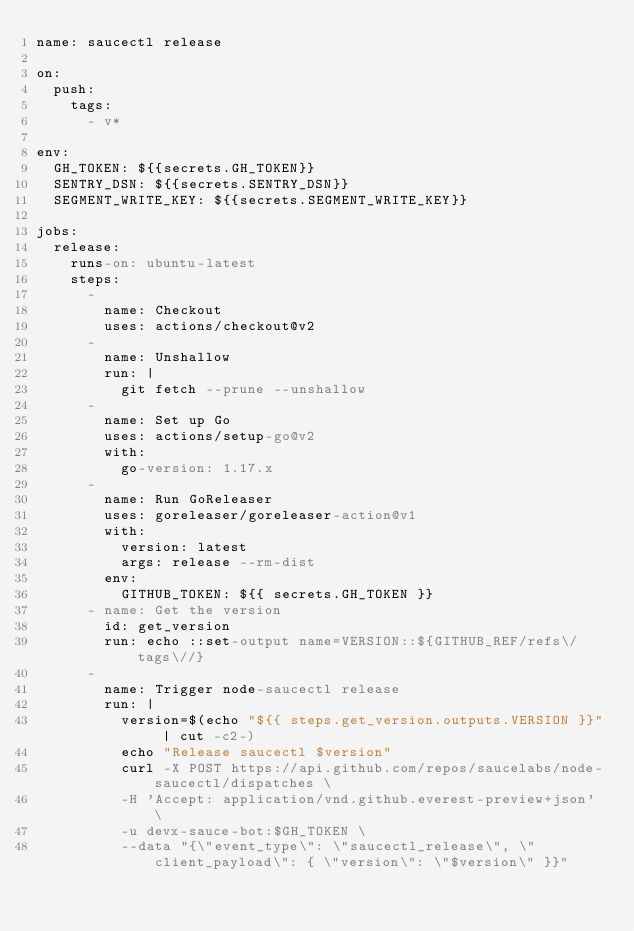<code> <loc_0><loc_0><loc_500><loc_500><_YAML_>name: saucectl release

on:
  push:
    tags:
      - v*

env:
  GH_TOKEN: ${{secrets.GH_TOKEN}}
  SENTRY_DSN: ${{secrets.SENTRY_DSN}}
  SEGMENT_WRITE_KEY: ${{secrets.SEGMENT_WRITE_KEY}}

jobs:
  release:
    runs-on: ubuntu-latest
    steps:
      -
        name: Checkout
        uses: actions/checkout@v2
      -
        name: Unshallow
        run: |
          git fetch --prune --unshallow
      -
        name: Set up Go
        uses: actions/setup-go@v2
        with:
          go-version: 1.17.x
      -
        name: Run GoReleaser
        uses: goreleaser/goreleaser-action@v1
        with:
          version: latest
          args: release --rm-dist
        env:
          GITHUB_TOKEN: ${{ secrets.GH_TOKEN }}
      - name: Get the version
        id: get_version
        run: echo ::set-output name=VERSION::${GITHUB_REF/refs\/tags\//}
      -
        name: Trigger node-saucectl release
        run: |
          version=$(echo "${{ steps.get_version.outputs.VERSION }}" | cut -c2-)
          echo "Release saucectl $version"
          curl -X POST https://api.github.com/repos/saucelabs/node-saucectl/dispatches \
          -H 'Accept: application/vnd.github.everest-preview+json' \
          -u devx-sauce-bot:$GH_TOKEN \
          --data "{\"event_type\": \"saucectl_release\", \"client_payload\": { \"version\": \"$version\" }}"</code> 